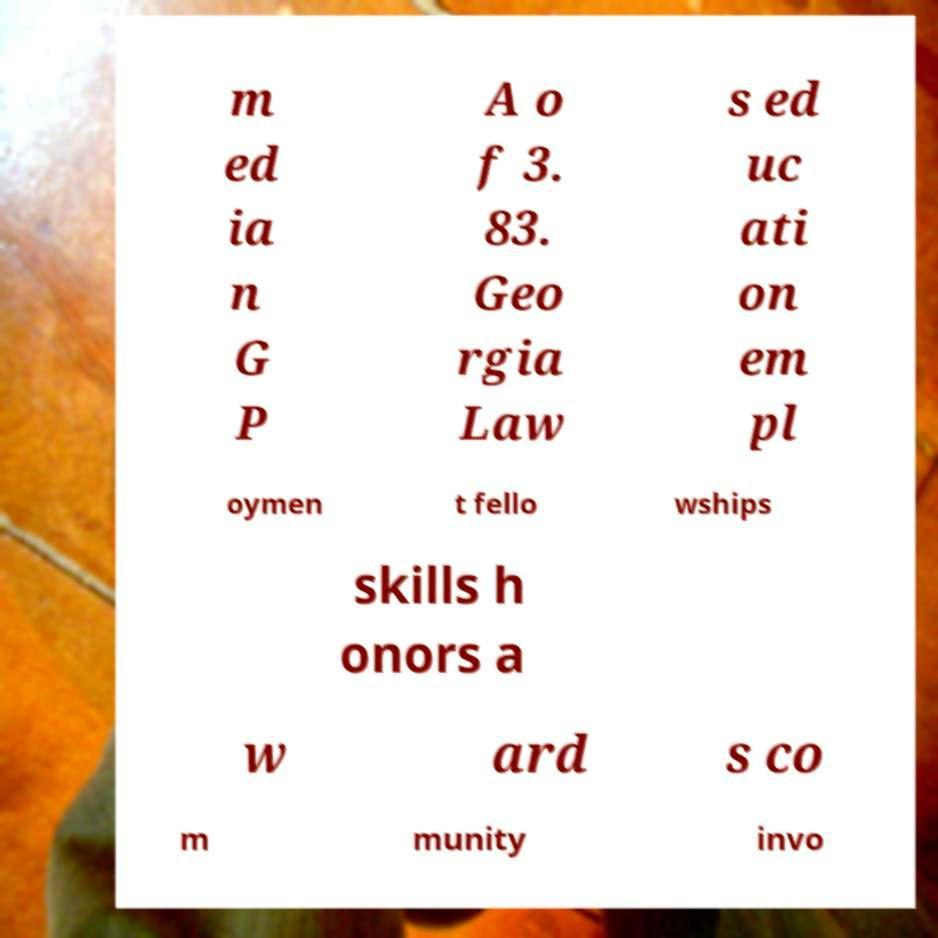Can you accurately transcribe the text from the provided image for me? m ed ia n G P A o f 3. 83. Geo rgia Law s ed uc ati on em pl oymen t fello wships skills h onors a w ard s co m munity invo 